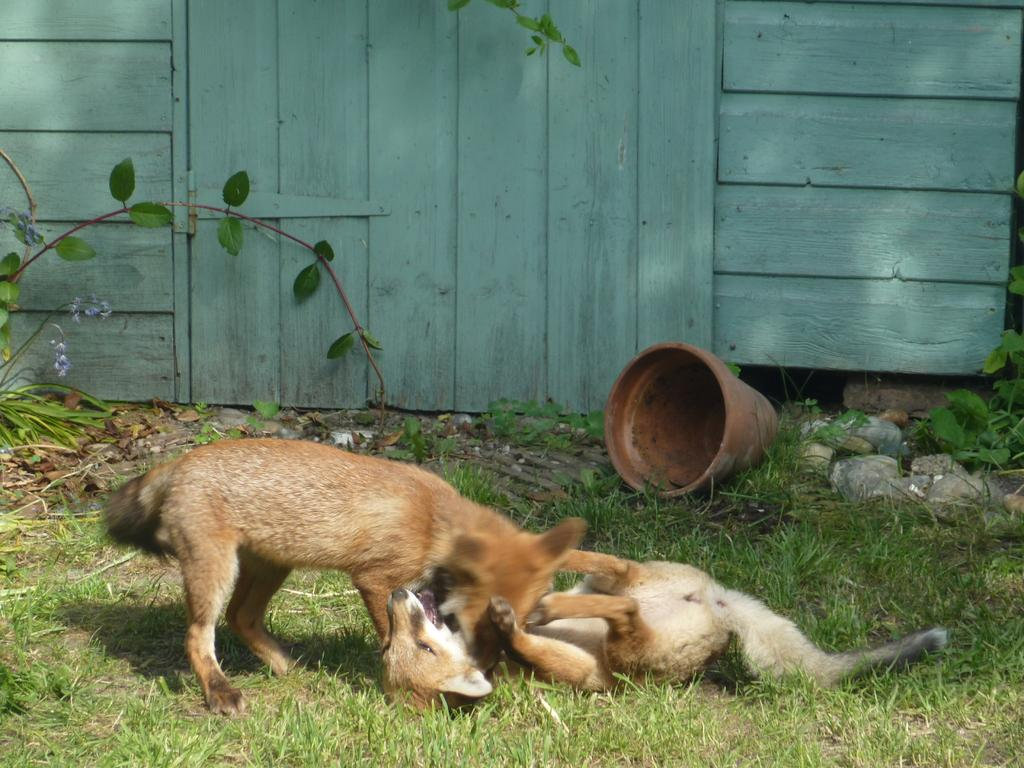What can be seen on the ground in the image? There are two animals on the ground in the image. What object is present near the animals? There is a flower pot in the image. What type of material is visible in the image? Stones are present in the image. What type of vegetation is visible in the image? Plants are visible in the image. What architectural feature can be seen in the background of the image? There is a wooden wall with a door in the background of the image. What type of stocking is the elbow wearing in the image? There is no stocking or elbow present in the image; it features two animals, a flower pot, stones, plants, and a wooden wall with a door. 